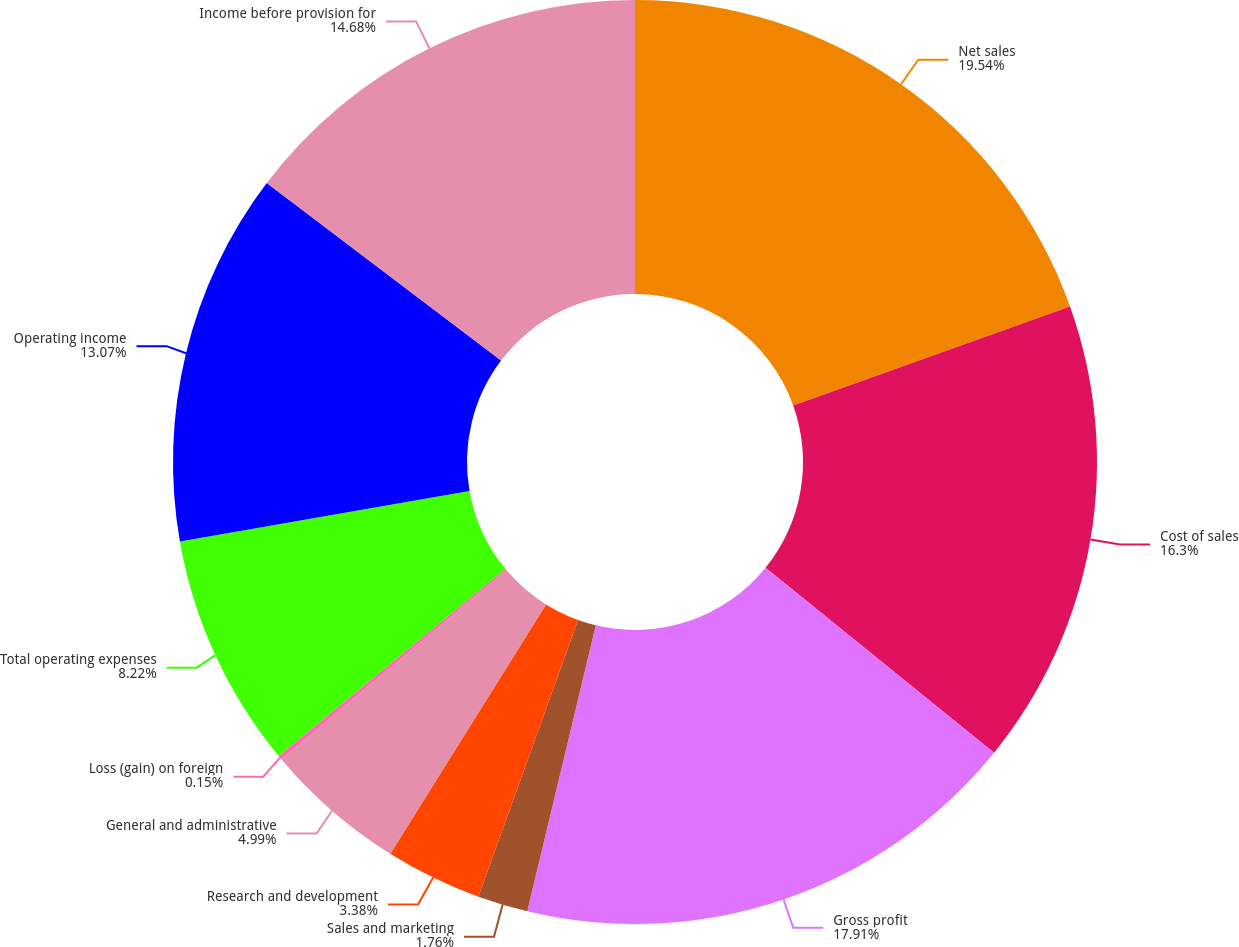Convert chart. <chart><loc_0><loc_0><loc_500><loc_500><pie_chart><fcel>Net sales<fcel>Cost of sales<fcel>Gross profit<fcel>Sales and marketing<fcel>Research and development<fcel>General and administrative<fcel>Loss (gain) on foreign<fcel>Total operating expenses<fcel>Operating income<fcel>Income before provision for<nl><fcel>19.53%<fcel>16.3%<fcel>17.91%<fcel>1.76%<fcel>3.38%<fcel>4.99%<fcel>0.15%<fcel>8.22%<fcel>13.07%<fcel>14.68%<nl></chart> 